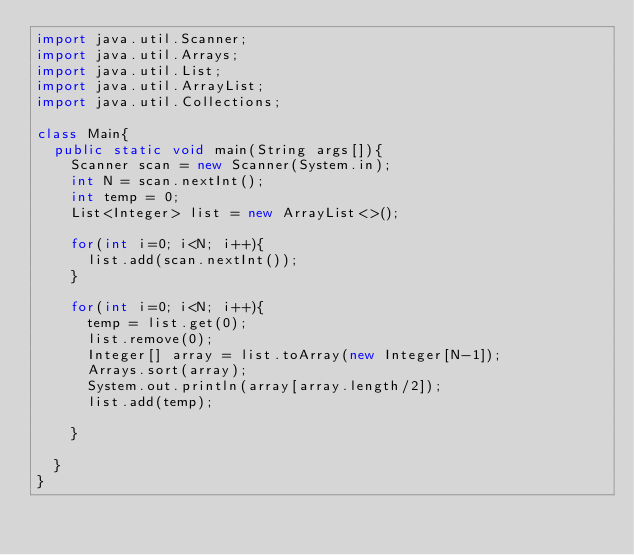Convert code to text. <code><loc_0><loc_0><loc_500><loc_500><_Java_>import java.util.Scanner;
import java.util.Arrays;
import java.util.List;
import java.util.ArrayList;
import java.util.Collections;

class Main{
  public static void main(String args[]){
    Scanner scan = new Scanner(System.in);
    int N = scan.nextInt();
    int temp = 0;
    List<Integer> list = new ArrayList<>();

    for(int i=0; i<N; i++){
      list.add(scan.nextInt());
    }

    for(int i=0; i<N; i++){
      temp = list.get(0);
      list.remove(0);
      Integer[] array = list.toArray(new Integer[N-1]);
      Arrays.sort(array);
      System.out.println(array[array.length/2]);
      list.add(temp);

    }

  }
}
</code> 